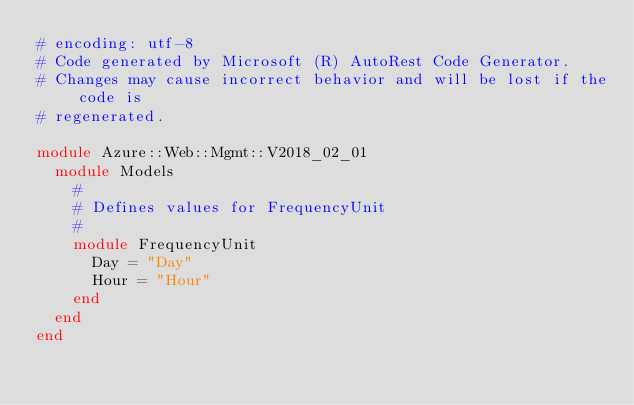<code> <loc_0><loc_0><loc_500><loc_500><_Ruby_># encoding: utf-8
# Code generated by Microsoft (R) AutoRest Code Generator.
# Changes may cause incorrect behavior and will be lost if the code is
# regenerated.

module Azure::Web::Mgmt::V2018_02_01
  module Models
    #
    # Defines values for FrequencyUnit
    #
    module FrequencyUnit
      Day = "Day"
      Hour = "Hour"
    end
  end
end
</code> 